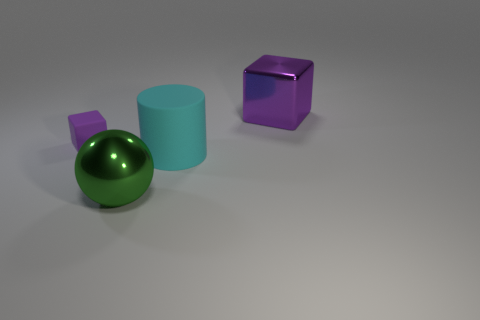Add 4 tiny purple cubes. How many objects exist? 8 Subtract all cylinders. How many objects are left? 3 Subtract 0 purple balls. How many objects are left? 4 Subtract all purple objects. Subtract all small metallic spheres. How many objects are left? 2 Add 4 large cyan cylinders. How many large cyan cylinders are left? 5 Add 3 big cyan rubber things. How many big cyan rubber things exist? 4 